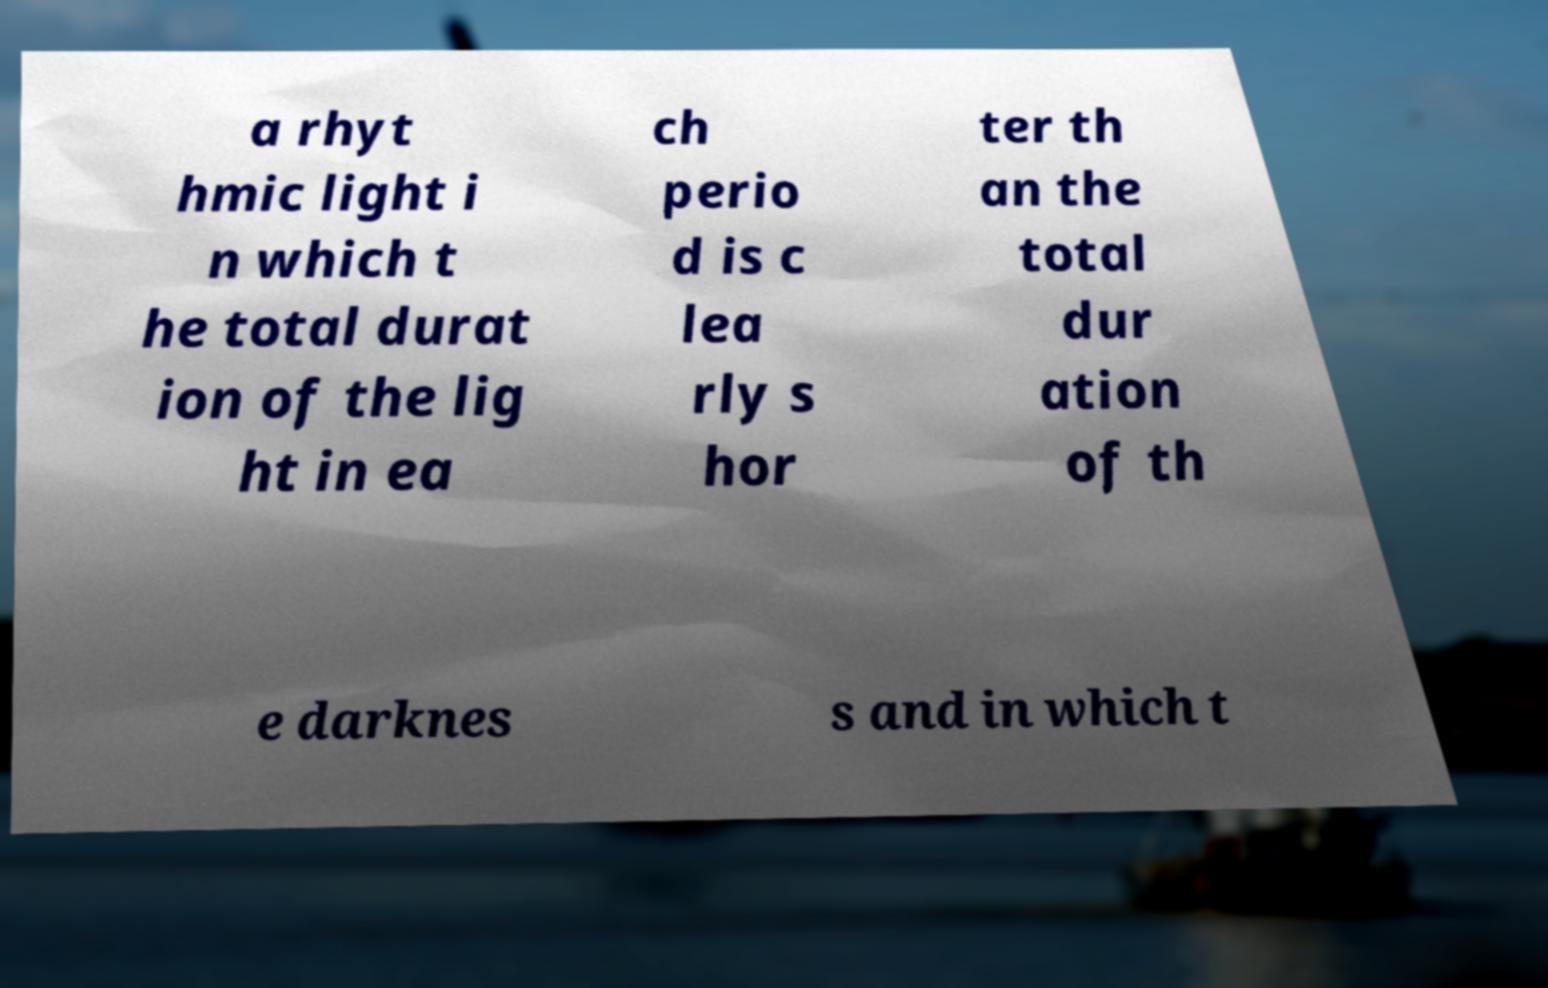Could you assist in decoding the text presented in this image and type it out clearly? a rhyt hmic light i n which t he total durat ion of the lig ht in ea ch perio d is c lea rly s hor ter th an the total dur ation of th e darknes s and in which t 